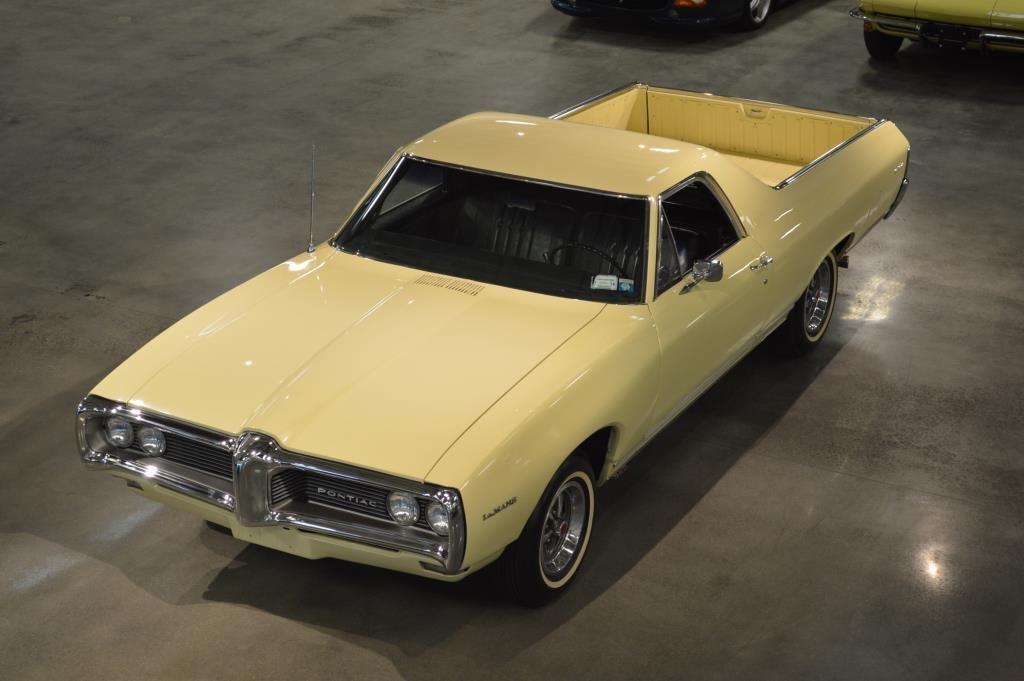Please provide a concise description of this image. In the picture I can see vehicles on the ground among them the car in front of the image is yellow in color. 